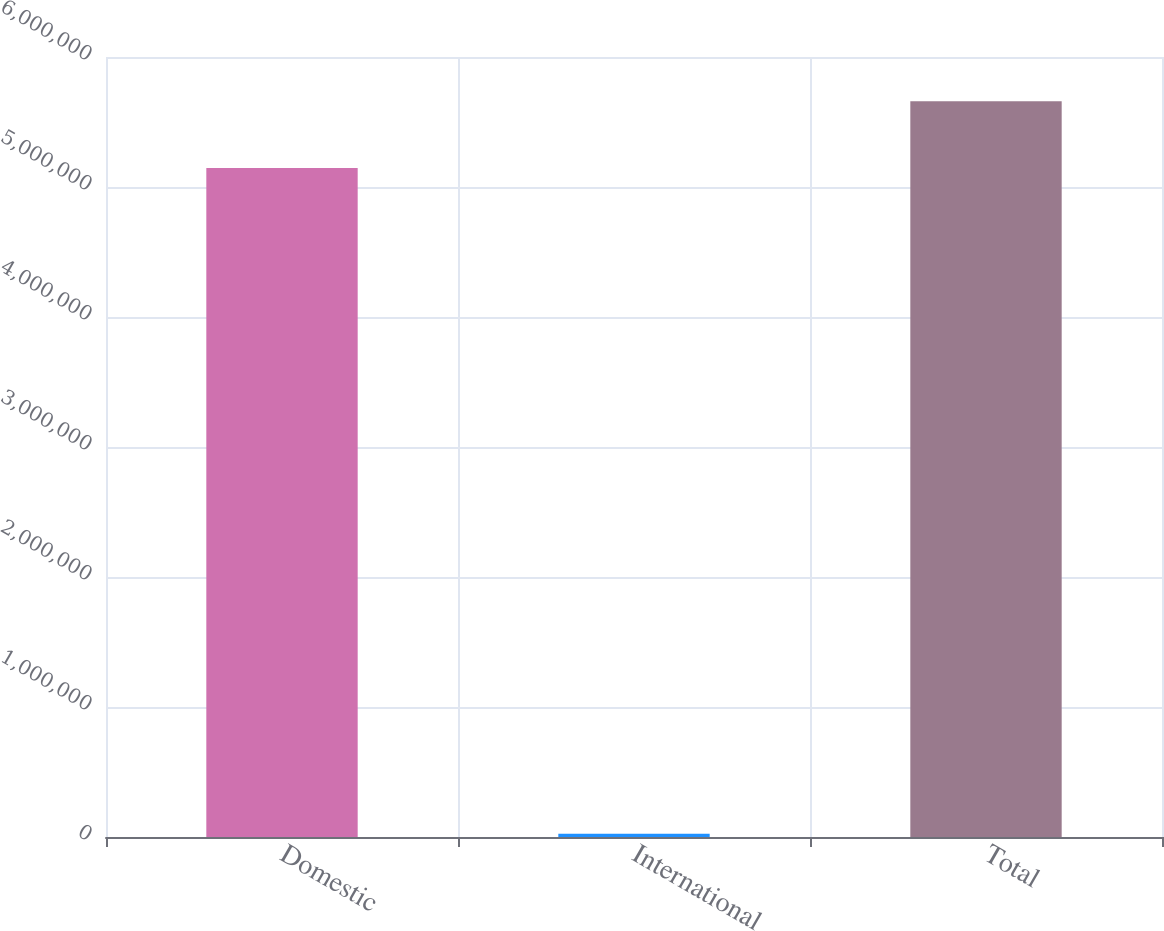Convert chart. <chart><loc_0><loc_0><loc_500><loc_500><bar_chart><fcel>Domestic<fcel>International<fcel>Total<nl><fcel>5.14553e+06<fcel>25513<fcel>5.66008e+06<nl></chart> 